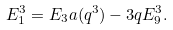<formula> <loc_0><loc_0><loc_500><loc_500>E _ { 1 } ^ { 3 } = E _ { 3 } a ( q ^ { 3 } ) - 3 q E _ { 9 } ^ { 3 } .</formula> 